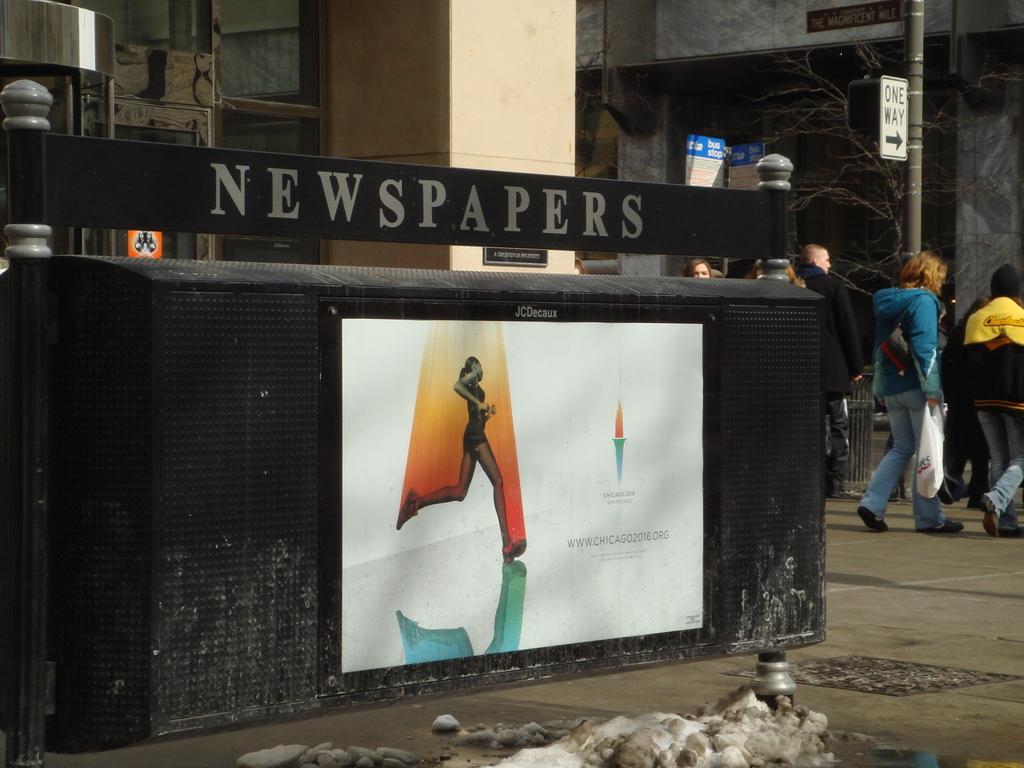Describe this image in one or two sentences. In this image I can see few persons. I can see a pole. I can see a poster on the wall. I can see some text. 